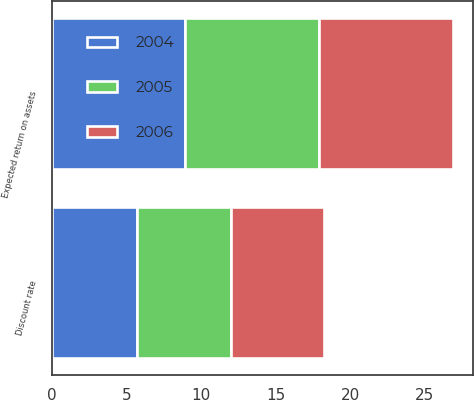<chart> <loc_0><loc_0><loc_500><loc_500><stacked_bar_chart><ecel><fcel>Discount rate<fcel>Expected return on assets<nl><fcel>2004<fcel>5.75<fcel>8.96<nl><fcel>2006<fcel>6.25<fcel>8.96<nl><fcel>2005<fcel>6.25<fcel>8.96<nl></chart> 